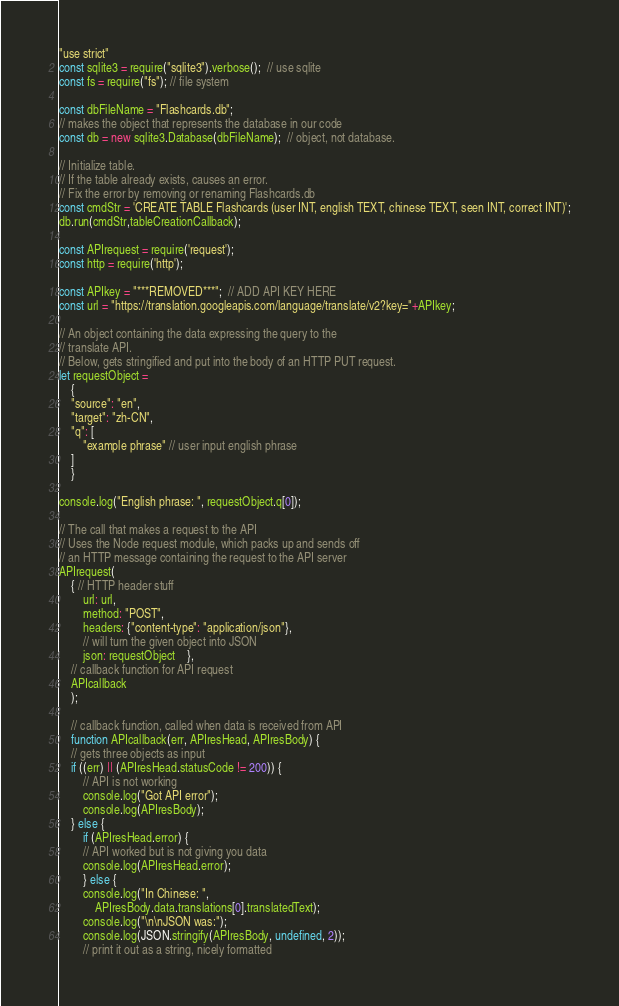<code> <loc_0><loc_0><loc_500><loc_500><_JavaScript_>"use strict"
const sqlite3 = require("sqlite3").verbose();  // use sqlite
const fs = require("fs"); // file system

const dbFileName = "Flashcards.db";
// makes the object that represents the database in our code
const db = new sqlite3.Database(dbFileName);  // object, not database.

// Initialize table.
// If the table already exists, causes an error.
// Fix the error by removing or renaming Flashcards.db
const cmdStr = 'CREATE TABLE Flashcards (user INT, english TEXT, chinese TEXT, seen INT, correct INT)';
db.run(cmdStr,tableCreationCallback);

const APIrequest = require('request');
const http = require('http');

const APIkey = "***REMOVED***";  // ADD API KEY HERE
const url = "https://translation.googleapis.com/language/translate/v2?key="+APIkey;

// An object containing the data expressing the query to the
// translate API. 
// Below, gets stringified and put into the body of an HTTP PUT request.
let requestObject = 
    {
	"source": "en",
	"target": "zh-CN",
	"q": [
	    "example phrase" // user input english phrase
	]
    }

console.log("English phrase: ", requestObject.q[0]);

// The call that makes a request to the API
// Uses the Node request module, which packs up and sends off
// an HTTP message containing the request to the API server
APIrequest(
	{ // HTTP header stuff
	    url: url,
	    method: "POST",
	    headers: {"content-type": "application/json"},
	    // will turn the given object into JSON
	    json: requestObject	},
	// callback function for API request
	APIcallback
    );

    // callback function, called when data is received from API
    function APIcallback(err, APIresHead, APIresBody) {
	// gets three objects as input
	if ((err) || (APIresHead.statusCode != 200)) {
	    // API is not working
	    console.log("Got API error");
	    console.log(APIresBody);
	} else {
	    if (APIresHead.error) {
		// API worked but is not giving you data
		console.log(APIresHead.error);
	    } else {
		console.log("In Chinese: ", 
		    APIresBody.data.translations[0].translatedText);
		console.log("\n\nJSON was:");
		console.log(JSON.stringify(APIresBody, undefined, 2));
        // print it out as a string, nicely formatted</code> 